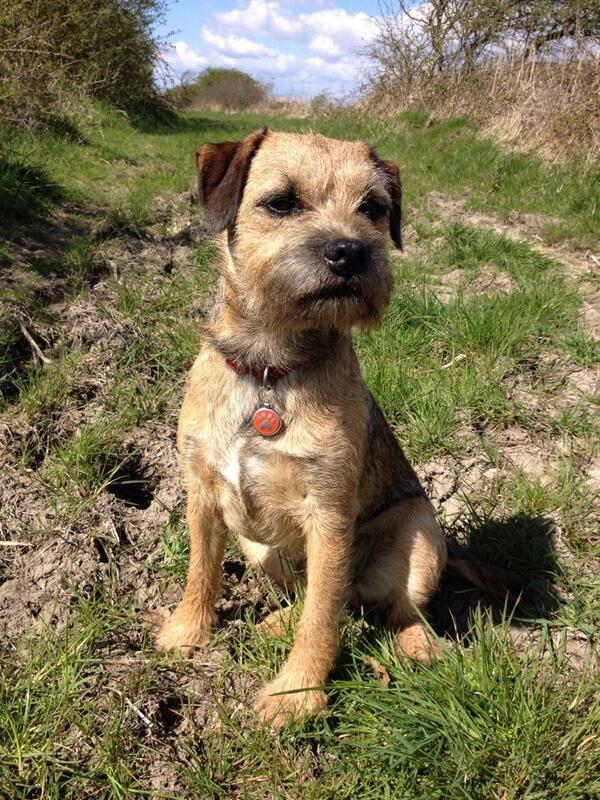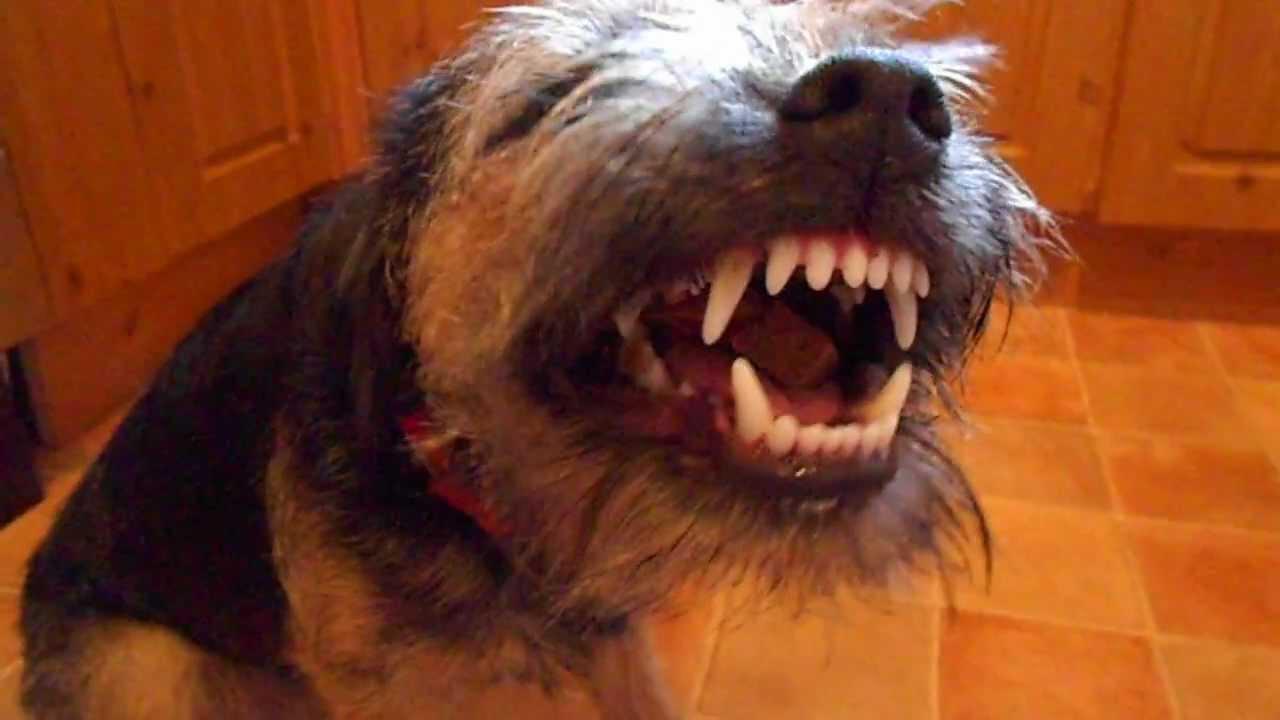The first image is the image on the left, the second image is the image on the right. Analyze the images presented: Is the assertion "There is a dog sitting upright inside in the right image." valid? Answer yes or no. No. The first image is the image on the left, the second image is the image on the right. For the images displayed, is the sentence "Atleast one image contains a sleeping or growling dog." factually correct? Answer yes or no. Yes. 